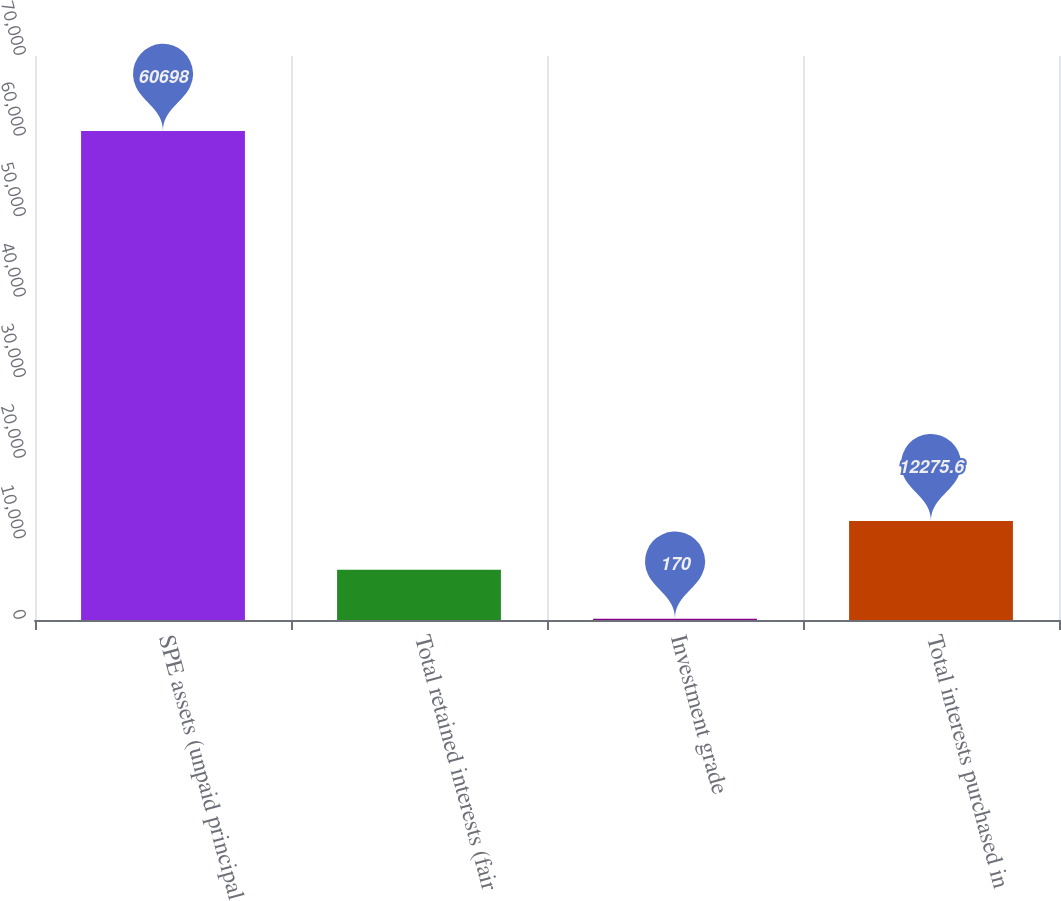Convert chart to OTSL. <chart><loc_0><loc_0><loc_500><loc_500><bar_chart><fcel>SPE assets (unpaid principal<fcel>Total retained interests (fair<fcel>Investment grade<fcel>Total interests purchased in<nl><fcel>60698<fcel>6222.8<fcel>170<fcel>12275.6<nl></chart> 